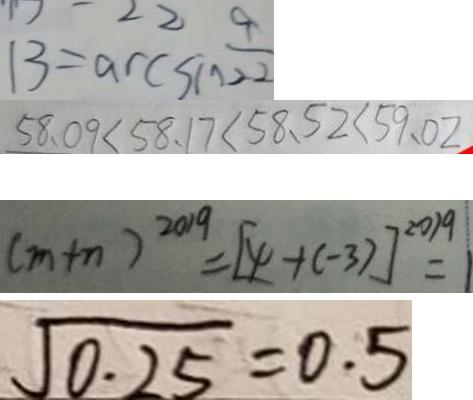Convert formula to latex. <formula><loc_0><loc_0><loc_500><loc_500>1 3 = \arcsin \frac { 9 } { 2 2 } 
 5 8 . 0 9 < 5 8 . 1 7 < 5 8 . 5 2 < 5 9 . 0 2 
 ( m + n ) ^ { 2 0 1 9 } = [ 4 + ( - 3 ) ] ^ { 2 0 1 9 } = 1 
 \sqrt { 0 . 2 5 } = 0 . 5</formula> 